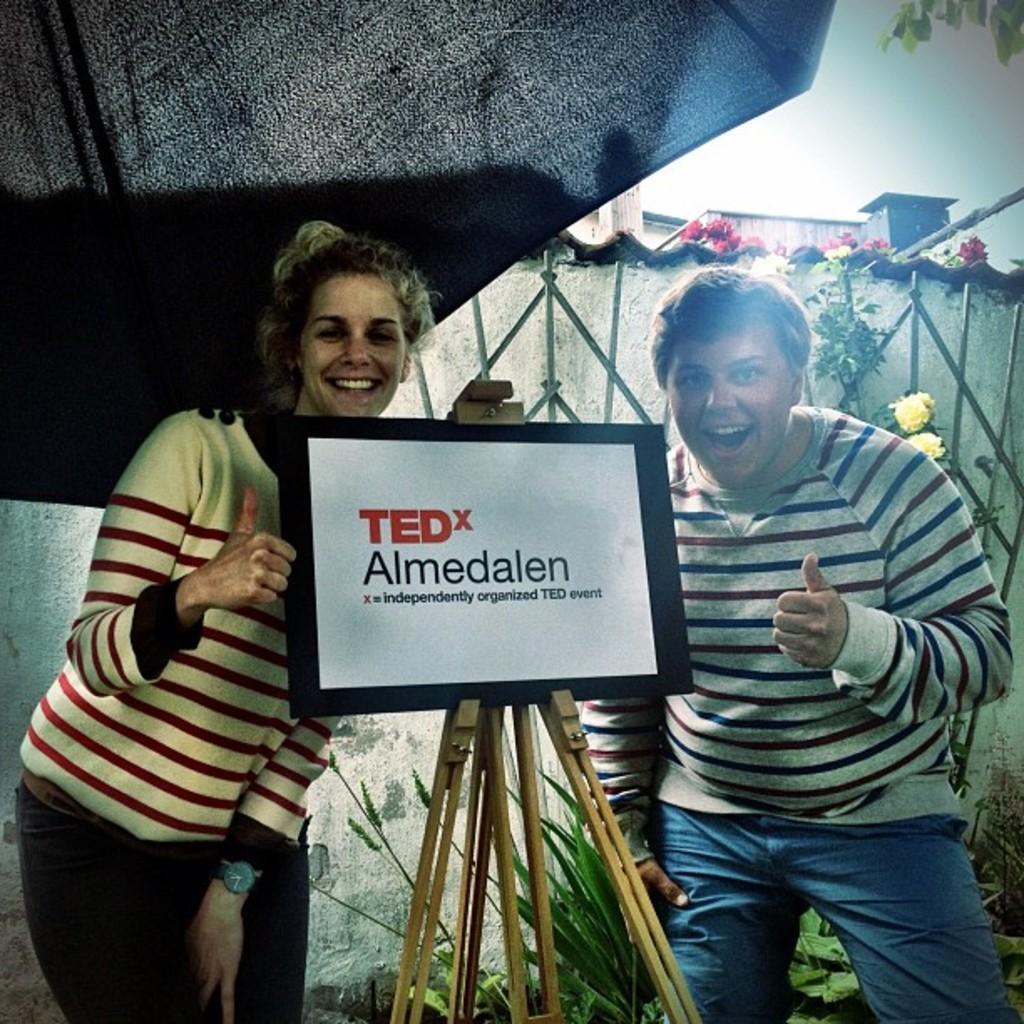How would you summarize this image in a sentence or two? In this image, we can see two ladies smiling and in the center of the image, there is a board placed to a stand and in the background, we can see a grill and there is a building and we can see some plants also. 